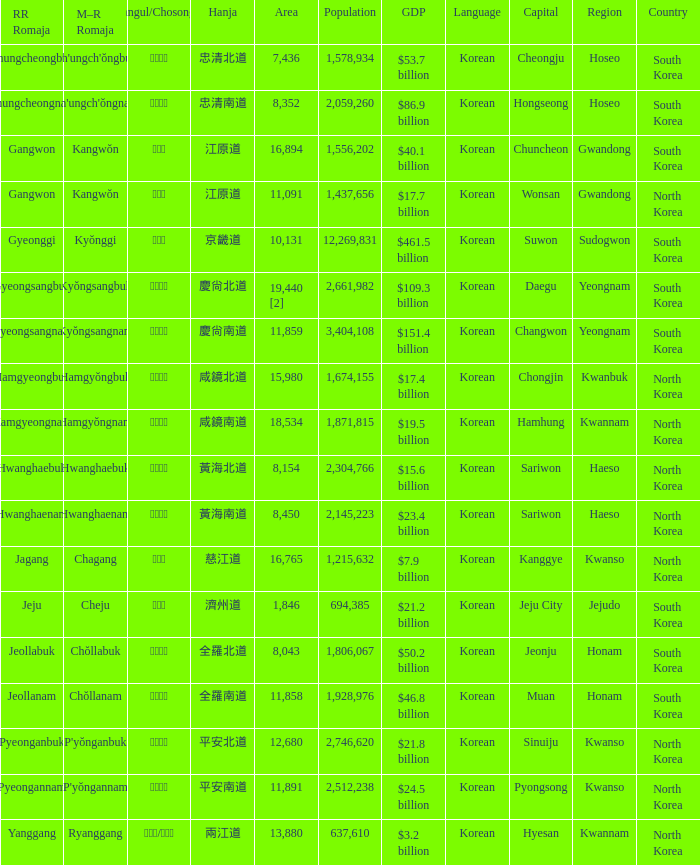Which capital has a Hangul of 경상남도? Changwon. 